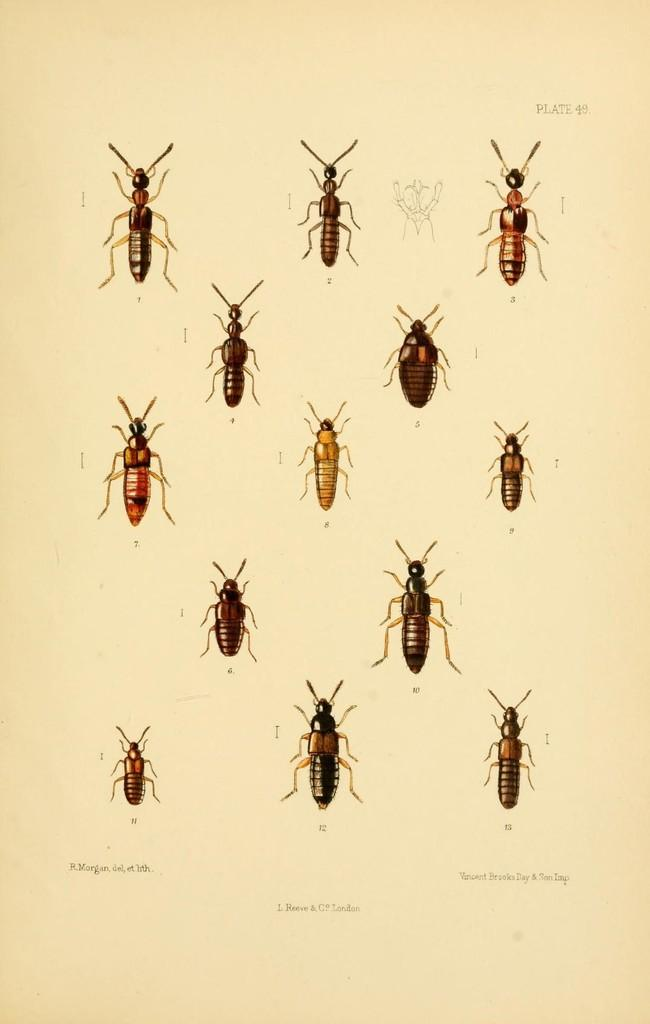What type of images are on the paper in the image? There are pictures of insects on the paper. What else can be seen on the paper besides the images? There is text visible in the image. What type of locket is the pig wearing in the image? There is no pig or locket present in the image; it features pictures of insects and text. Who is the achiever mentioned in the text in the image? The provided facts do not mention any specific achiever, so we cannot determine who it might be from the image. 